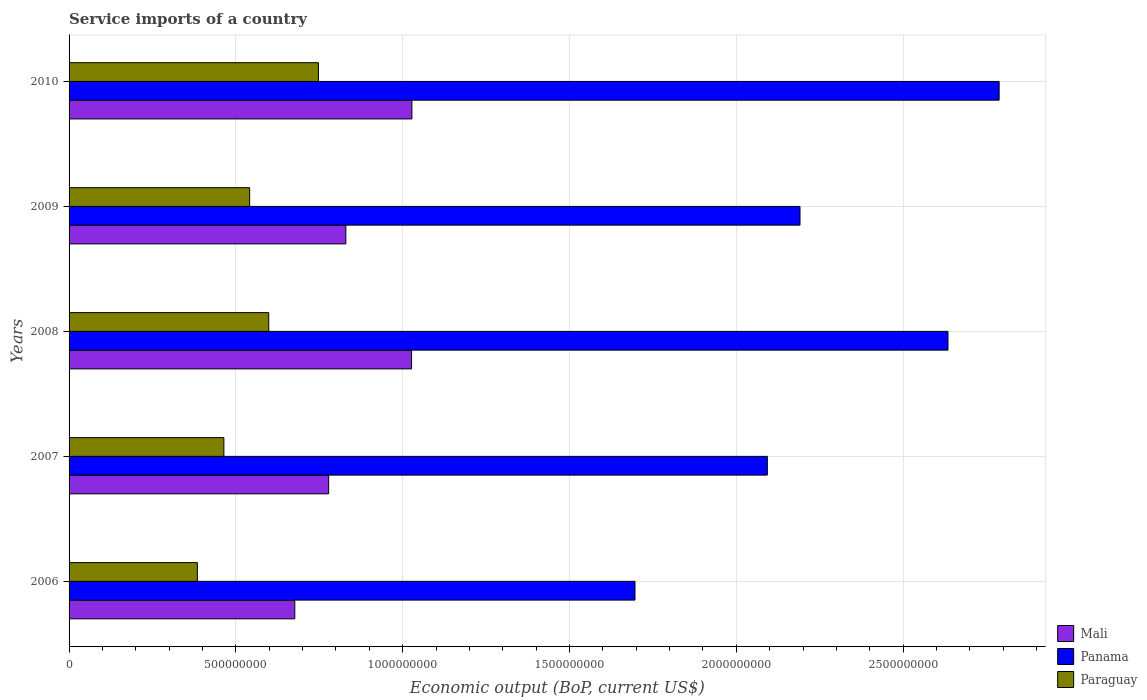Are the number of bars per tick equal to the number of legend labels?
Ensure brevity in your answer.  Yes. Are the number of bars on each tick of the Y-axis equal?
Offer a terse response. Yes. How many bars are there on the 3rd tick from the bottom?
Provide a short and direct response. 3. What is the label of the 4th group of bars from the top?
Your answer should be compact. 2007. What is the service imports in Panama in 2006?
Offer a very short reply. 1.70e+09. Across all years, what is the maximum service imports in Panama?
Ensure brevity in your answer.  2.79e+09. Across all years, what is the minimum service imports in Panama?
Ensure brevity in your answer.  1.70e+09. In which year was the service imports in Paraguay maximum?
Keep it short and to the point. 2010. What is the total service imports in Panama in the graph?
Offer a very short reply. 1.14e+1. What is the difference between the service imports in Panama in 2009 and that in 2010?
Your answer should be compact. -5.97e+08. What is the difference between the service imports in Mali in 2006 and the service imports in Paraguay in 2007?
Your answer should be very brief. 2.13e+08. What is the average service imports in Panama per year?
Your response must be concise. 2.28e+09. In the year 2006, what is the difference between the service imports in Panama and service imports in Mali?
Offer a terse response. 1.02e+09. What is the ratio of the service imports in Paraguay in 2006 to that in 2009?
Your answer should be compact. 0.71. Is the service imports in Panama in 2007 less than that in 2008?
Your answer should be compact. Yes. Is the difference between the service imports in Panama in 2008 and 2010 greater than the difference between the service imports in Mali in 2008 and 2010?
Your response must be concise. No. What is the difference between the highest and the second highest service imports in Panama?
Your answer should be very brief. 1.53e+08. What is the difference between the highest and the lowest service imports in Panama?
Offer a terse response. 1.09e+09. In how many years, is the service imports in Panama greater than the average service imports in Panama taken over all years?
Provide a short and direct response. 2. What does the 2nd bar from the top in 2007 represents?
Provide a short and direct response. Panama. What does the 1st bar from the bottom in 2010 represents?
Give a very brief answer. Mali. Is it the case that in every year, the sum of the service imports in Mali and service imports in Paraguay is greater than the service imports in Panama?
Ensure brevity in your answer.  No. How many bars are there?
Offer a very short reply. 15. What is the difference between two consecutive major ticks on the X-axis?
Give a very brief answer. 5.00e+08. Are the values on the major ticks of X-axis written in scientific E-notation?
Your answer should be compact. No. Does the graph contain any zero values?
Offer a very short reply. No. Does the graph contain grids?
Your response must be concise. Yes. Where does the legend appear in the graph?
Keep it short and to the point. Bottom right. How are the legend labels stacked?
Ensure brevity in your answer.  Vertical. What is the title of the graph?
Keep it short and to the point. Service imports of a country. What is the label or title of the X-axis?
Provide a succinct answer. Economic output (BoP, current US$). What is the label or title of the Y-axis?
Your response must be concise. Years. What is the Economic output (BoP, current US$) of Mali in 2006?
Offer a terse response. 6.77e+08. What is the Economic output (BoP, current US$) of Panama in 2006?
Ensure brevity in your answer.  1.70e+09. What is the Economic output (BoP, current US$) of Paraguay in 2006?
Offer a very short reply. 3.85e+08. What is the Economic output (BoP, current US$) in Mali in 2007?
Give a very brief answer. 7.78e+08. What is the Economic output (BoP, current US$) in Panama in 2007?
Your answer should be compact. 2.09e+09. What is the Economic output (BoP, current US$) in Paraguay in 2007?
Your answer should be very brief. 4.64e+08. What is the Economic output (BoP, current US$) in Mali in 2008?
Your response must be concise. 1.03e+09. What is the Economic output (BoP, current US$) of Panama in 2008?
Your response must be concise. 2.63e+09. What is the Economic output (BoP, current US$) of Paraguay in 2008?
Make the answer very short. 5.99e+08. What is the Economic output (BoP, current US$) in Mali in 2009?
Offer a terse response. 8.30e+08. What is the Economic output (BoP, current US$) of Panama in 2009?
Keep it short and to the point. 2.19e+09. What is the Economic output (BoP, current US$) in Paraguay in 2009?
Your response must be concise. 5.41e+08. What is the Economic output (BoP, current US$) in Mali in 2010?
Keep it short and to the point. 1.03e+09. What is the Economic output (BoP, current US$) of Panama in 2010?
Your response must be concise. 2.79e+09. What is the Economic output (BoP, current US$) in Paraguay in 2010?
Give a very brief answer. 7.47e+08. Across all years, what is the maximum Economic output (BoP, current US$) of Mali?
Your response must be concise. 1.03e+09. Across all years, what is the maximum Economic output (BoP, current US$) in Panama?
Give a very brief answer. 2.79e+09. Across all years, what is the maximum Economic output (BoP, current US$) of Paraguay?
Offer a terse response. 7.47e+08. Across all years, what is the minimum Economic output (BoP, current US$) of Mali?
Provide a succinct answer. 6.77e+08. Across all years, what is the minimum Economic output (BoP, current US$) of Panama?
Your answer should be compact. 1.70e+09. Across all years, what is the minimum Economic output (BoP, current US$) of Paraguay?
Provide a short and direct response. 3.85e+08. What is the total Economic output (BoP, current US$) in Mali in the graph?
Give a very brief answer. 4.34e+09. What is the total Economic output (BoP, current US$) in Panama in the graph?
Offer a very short reply. 1.14e+1. What is the total Economic output (BoP, current US$) in Paraguay in the graph?
Offer a terse response. 2.74e+09. What is the difference between the Economic output (BoP, current US$) of Mali in 2006 and that in 2007?
Make the answer very short. -1.02e+08. What is the difference between the Economic output (BoP, current US$) in Panama in 2006 and that in 2007?
Your answer should be compact. -3.97e+08. What is the difference between the Economic output (BoP, current US$) in Paraguay in 2006 and that in 2007?
Offer a very short reply. -7.95e+07. What is the difference between the Economic output (BoP, current US$) of Mali in 2006 and that in 2008?
Give a very brief answer. -3.50e+08. What is the difference between the Economic output (BoP, current US$) of Panama in 2006 and that in 2008?
Your response must be concise. -9.38e+08. What is the difference between the Economic output (BoP, current US$) in Paraguay in 2006 and that in 2008?
Offer a terse response. -2.14e+08. What is the difference between the Economic output (BoP, current US$) of Mali in 2006 and that in 2009?
Offer a very short reply. -1.53e+08. What is the difference between the Economic output (BoP, current US$) of Panama in 2006 and that in 2009?
Provide a short and direct response. -4.95e+08. What is the difference between the Economic output (BoP, current US$) in Paraguay in 2006 and that in 2009?
Keep it short and to the point. -1.57e+08. What is the difference between the Economic output (BoP, current US$) of Mali in 2006 and that in 2010?
Your answer should be compact. -3.51e+08. What is the difference between the Economic output (BoP, current US$) of Panama in 2006 and that in 2010?
Provide a succinct answer. -1.09e+09. What is the difference between the Economic output (BoP, current US$) of Paraguay in 2006 and that in 2010?
Your answer should be compact. -3.63e+08. What is the difference between the Economic output (BoP, current US$) in Mali in 2007 and that in 2008?
Your answer should be compact. -2.48e+08. What is the difference between the Economic output (BoP, current US$) in Panama in 2007 and that in 2008?
Give a very brief answer. -5.41e+08. What is the difference between the Economic output (BoP, current US$) in Paraguay in 2007 and that in 2008?
Keep it short and to the point. -1.35e+08. What is the difference between the Economic output (BoP, current US$) in Mali in 2007 and that in 2009?
Provide a short and direct response. -5.15e+07. What is the difference between the Economic output (BoP, current US$) of Panama in 2007 and that in 2009?
Provide a succinct answer. -9.79e+07. What is the difference between the Economic output (BoP, current US$) in Paraguay in 2007 and that in 2009?
Offer a very short reply. -7.72e+07. What is the difference between the Economic output (BoP, current US$) of Mali in 2007 and that in 2010?
Make the answer very short. -2.49e+08. What is the difference between the Economic output (BoP, current US$) in Panama in 2007 and that in 2010?
Offer a terse response. -6.95e+08. What is the difference between the Economic output (BoP, current US$) in Paraguay in 2007 and that in 2010?
Your answer should be very brief. -2.83e+08. What is the difference between the Economic output (BoP, current US$) in Mali in 2008 and that in 2009?
Offer a very short reply. 1.97e+08. What is the difference between the Economic output (BoP, current US$) in Panama in 2008 and that in 2009?
Your answer should be very brief. 4.44e+08. What is the difference between the Economic output (BoP, current US$) of Paraguay in 2008 and that in 2009?
Your response must be concise. 5.73e+07. What is the difference between the Economic output (BoP, current US$) of Mali in 2008 and that in 2010?
Your answer should be very brief. -1.00e+06. What is the difference between the Economic output (BoP, current US$) of Panama in 2008 and that in 2010?
Give a very brief answer. -1.53e+08. What is the difference between the Economic output (BoP, current US$) in Paraguay in 2008 and that in 2010?
Keep it short and to the point. -1.49e+08. What is the difference between the Economic output (BoP, current US$) in Mali in 2009 and that in 2010?
Make the answer very short. -1.98e+08. What is the difference between the Economic output (BoP, current US$) of Panama in 2009 and that in 2010?
Offer a terse response. -5.97e+08. What is the difference between the Economic output (BoP, current US$) of Paraguay in 2009 and that in 2010?
Your answer should be compact. -2.06e+08. What is the difference between the Economic output (BoP, current US$) in Mali in 2006 and the Economic output (BoP, current US$) in Panama in 2007?
Give a very brief answer. -1.42e+09. What is the difference between the Economic output (BoP, current US$) in Mali in 2006 and the Economic output (BoP, current US$) in Paraguay in 2007?
Your answer should be very brief. 2.13e+08. What is the difference between the Economic output (BoP, current US$) of Panama in 2006 and the Economic output (BoP, current US$) of Paraguay in 2007?
Provide a succinct answer. 1.23e+09. What is the difference between the Economic output (BoP, current US$) of Mali in 2006 and the Economic output (BoP, current US$) of Panama in 2008?
Make the answer very short. -1.96e+09. What is the difference between the Economic output (BoP, current US$) of Mali in 2006 and the Economic output (BoP, current US$) of Paraguay in 2008?
Offer a terse response. 7.81e+07. What is the difference between the Economic output (BoP, current US$) of Panama in 2006 and the Economic output (BoP, current US$) of Paraguay in 2008?
Your response must be concise. 1.10e+09. What is the difference between the Economic output (BoP, current US$) in Mali in 2006 and the Economic output (BoP, current US$) in Panama in 2009?
Make the answer very short. -1.51e+09. What is the difference between the Economic output (BoP, current US$) in Mali in 2006 and the Economic output (BoP, current US$) in Paraguay in 2009?
Give a very brief answer. 1.35e+08. What is the difference between the Economic output (BoP, current US$) of Panama in 2006 and the Economic output (BoP, current US$) of Paraguay in 2009?
Make the answer very short. 1.16e+09. What is the difference between the Economic output (BoP, current US$) of Mali in 2006 and the Economic output (BoP, current US$) of Panama in 2010?
Provide a short and direct response. -2.11e+09. What is the difference between the Economic output (BoP, current US$) in Mali in 2006 and the Economic output (BoP, current US$) in Paraguay in 2010?
Offer a terse response. -7.08e+07. What is the difference between the Economic output (BoP, current US$) of Panama in 2006 and the Economic output (BoP, current US$) of Paraguay in 2010?
Keep it short and to the point. 9.49e+08. What is the difference between the Economic output (BoP, current US$) of Mali in 2007 and the Economic output (BoP, current US$) of Panama in 2008?
Provide a short and direct response. -1.86e+09. What is the difference between the Economic output (BoP, current US$) of Mali in 2007 and the Economic output (BoP, current US$) of Paraguay in 2008?
Offer a very short reply. 1.80e+08. What is the difference between the Economic output (BoP, current US$) in Panama in 2007 and the Economic output (BoP, current US$) in Paraguay in 2008?
Keep it short and to the point. 1.49e+09. What is the difference between the Economic output (BoP, current US$) in Mali in 2007 and the Economic output (BoP, current US$) in Panama in 2009?
Provide a short and direct response. -1.41e+09. What is the difference between the Economic output (BoP, current US$) in Mali in 2007 and the Economic output (BoP, current US$) in Paraguay in 2009?
Ensure brevity in your answer.  2.37e+08. What is the difference between the Economic output (BoP, current US$) of Panama in 2007 and the Economic output (BoP, current US$) of Paraguay in 2009?
Your answer should be very brief. 1.55e+09. What is the difference between the Economic output (BoP, current US$) in Mali in 2007 and the Economic output (BoP, current US$) in Panama in 2010?
Your answer should be very brief. -2.01e+09. What is the difference between the Economic output (BoP, current US$) of Mali in 2007 and the Economic output (BoP, current US$) of Paraguay in 2010?
Ensure brevity in your answer.  3.07e+07. What is the difference between the Economic output (BoP, current US$) in Panama in 2007 and the Economic output (BoP, current US$) in Paraguay in 2010?
Provide a succinct answer. 1.35e+09. What is the difference between the Economic output (BoP, current US$) in Mali in 2008 and the Economic output (BoP, current US$) in Panama in 2009?
Offer a very short reply. -1.16e+09. What is the difference between the Economic output (BoP, current US$) of Mali in 2008 and the Economic output (BoP, current US$) of Paraguay in 2009?
Make the answer very short. 4.85e+08. What is the difference between the Economic output (BoP, current US$) in Panama in 2008 and the Economic output (BoP, current US$) in Paraguay in 2009?
Provide a succinct answer. 2.09e+09. What is the difference between the Economic output (BoP, current US$) in Mali in 2008 and the Economic output (BoP, current US$) in Panama in 2010?
Keep it short and to the point. -1.76e+09. What is the difference between the Economic output (BoP, current US$) in Mali in 2008 and the Economic output (BoP, current US$) in Paraguay in 2010?
Ensure brevity in your answer.  2.79e+08. What is the difference between the Economic output (BoP, current US$) in Panama in 2008 and the Economic output (BoP, current US$) in Paraguay in 2010?
Give a very brief answer. 1.89e+09. What is the difference between the Economic output (BoP, current US$) in Mali in 2009 and the Economic output (BoP, current US$) in Panama in 2010?
Provide a short and direct response. -1.96e+09. What is the difference between the Economic output (BoP, current US$) in Mali in 2009 and the Economic output (BoP, current US$) in Paraguay in 2010?
Ensure brevity in your answer.  8.21e+07. What is the difference between the Economic output (BoP, current US$) in Panama in 2009 and the Economic output (BoP, current US$) in Paraguay in 2010?
Offer a terse response. 1.44e+09. What is the average Economic output (BoP, current US$) in Mali per year?
Ensure brevity in your answer.  8.68e+08. What is the average Economic output (BoP, current US$) of Panama per year?
Provide a succinct answer. 2.28e+09. What is the average Economic output (BoP, current US$) of Paraguay per year?
Offer a very short reply. 5.47e+08. In the year 2006, what is the difference between the Economic output (BoP, current US$) of Mali and Economic output (BoP, current US$) of Panama?
Your answer should be compact. -1.02e+09. In the year 2006, what is the difference between the Economic output (BoP, current US$) of Mali and Economic output (BoP, current US$) of Paraguay?
Ensure brevity in your answer.  2.92e+08. In the year 2006, what is the difference between the Economic output (BoP, current US$) in Panama and Economic output (BoP, current US$) in Paraguay?
Provide a succinct answer. 1.31e+09. In the year 2007, what is the difference between the Economic output (BoP, current US$) of Mali and Economic output (BoP, current US$) of Panama?
Make the answer very short. -1.31e+09. In the year 2007, what is the difference between the Economic output (BoP, current US$) in Mali and Economic output (BoP, current US$) in Paraguay?
Your response must be concise. 3.14e+08. In the year 2007, what is the difference between the Economic output (BoP, current US$) in Panama and Economic output (BoP, current US$) in Paraguay?
Give a very brief answer. 1.63e+09. In the year 2008, what is the difference between the Economic output (BoP, current US$) of Mali and Economic output (BoP, current US$) of Panama?
Give a very brief answer. -1.61e+09. In the year 2008, what is the difference between the Economic output (BoP, current US$) in Mali and Economic output (BoP, current US$) in Paraguay?
Offer a terse response. 4.28e+08. In the year 2008, what is the difference between the Economic output (BoP, current US$) in Panama and Economic output (BoP, current US$) in Paraguay?
Ensure brevity in your answer.  2.04e+09. In the year 2009, what is the difference between the Economic output (BoP, current US$) in Mali and Economic output (BoP, current US$) in Panama?
Provide a succinct answer. -1.36e+09. In the year 2009, what is the difference between the Economic output (BoP, current US$) in Mali and Economic output (BoP, current US$) in Paraguay?
Provide a short and direct response. 2.88e+08. In the year 2009, what is the difference between the Economic output (BoP, current US$) in Panama and Economic output (BoP, current US$) in Paraguay?
Your answer should be compact. 1.65e+09. In the year 2010, what is the difference between the Economic output (BoP, current US$) in Mali and Economic output (BoP, current US$) in Panama?
Make the answer very short. -1.76e+09. In the year 2010, what is the difference between the Economic output (BoP, current US$) of Mali and Economic output (BoP, current US$) of Paraguay?
Your answer should be very brief. 2.80e+08. In the year 2010, what is the difference between the Economic output (BoP, current US$) of Panama and Economic output (BoP, current US$) of Paraguay?
Give a very brief answer. 2.04e+09. What is the ratio of the Economic output (BoP, current US$) of Mali in 2006 to that in 2007?
Give a very brief answer. 0.87. What is the ratio of the Economic output (BoP, current US$) of Panama in 2006 to that in 2007?
Offer a very short reply. 0.81. What is the ratio of the Economic output (BoP, current US$) of Paraguay in 2006 to that in 2007?
Make the answer very short. 0.83. What is the ratio of the Economic output (BoP, current US$) of Mali in 2006 to that in 2008?
Make the answer very short. 0.66. What is the ratio of the Economic output (BoP, current US$) in Panama in 2006 to that in 2008?
Keep it short and to the point. 0.64. What is the ratio of the Economic output (BoP, current US$) of Paraguay in 2006 to that in 2008?
Your answer should be very brief. 0.64. What is the ratio of the Economic output (BoP, current US$) of Mali in 2006 to that in 2009?
Keep it short and to the point. 0.82. What is the ratio of the Economic output (BoP, current US$) in Panama in 2006 to that in 2009?
Keep it short and to the point. 0.77. What is the ratio of the Economic output (BoP, current US$) of Paraguay in 2006 to that in 2009?
Your answer should be compact. 0.71. What is the ratio of the Economic output (BoP, current US$) of Mali in 2006 to that in 2010?
Provide a short and direct response. 0.66. What is the ratio of the Economic output (BoP, current US$) in Panama in 2006 to that in 2010?
Provide a succinct answer. 0.61. What is the ratio of the Economic output (BoP, current US$) in Paraguay in 2006 to that in 2010?
Your answer should be compact. 0.51. What is the ratio of the Economic output (BoP, current US$) of Mali in 2007 to that in 2008?
Provide a short and direct response. 0.76. What is the ratio of the Economic output (BoP, current US$) of Panama in 2007 to that in 2008?
Offer a terse response. 0.79. What is the ratio of the Economic output (BoP, current US$) in Paraguay in 2007 to that in 2008?
Make the answer very short. 0.78. What is the ratio of the Economic output (BoP, current US$) in Mali in 2007 to that in 2009?
Ensure brevity in your answer.  0.94. What is the ratio of the Economic output (BoP, current US$) in Panama in 2007 to that in 2009?
Offer a terse response. 0.96. What is the ratio of the Economic output (BoP, current US$) in Paraguay in 2007 to that in 2009?
Provide a short and direct response. 0.86. What is the ratio of the Economic output (BoP, current US$) of Mali in 2007 to that in 2010?
Your response must be concise. 0.76. What is the ratio of the Economic output (BoP, current US$) in Panama in 2007 to that in 2010?
Offer a terse response. 0.75. What is the ratio of the Economic output (BoP, current US$) in Paraguay in 2007 to that in 2010?
Offer a terse response. 0.62. What is the ratio of the Economic output (BoP, current US$) of Mali in 2008 to that in 2009?
Give a very brief answer. 1.24. What is the ratio of the Economic output (BoP, current US$) of Panama in 2008 to that in 2009?
Your response must be concise. 1.2. What is the ratio of the Economic output (BoP, current US$) of Paraguay in 2008 to that in 2009?
Keep it short and to the point. 1.11. What is the ratio of the Economic output (BoP, current US$) in Mali in 2008 to that in 2010?
Offer a very short reply. 1. What is the ratio of the Economic output (BoP, current US$) in Panama in 2008 to that in 2010?
Provide a succinct answer. 0.94. What is the ratio of the Economic output (BoP, current US$) in Paraguay in 2008 to that in 2010?
Keep it short and to the point. 0.8. What is the ratio of the Economic output (BoP, current US$) of Mali in 2009 to that in 2010?
Provide a short and direct response. 0.81. What is the ratio of the Economic output (BoP, current US$) in Panama in 2009 to that in 2010?
Offer a terse response. 0.79. What is the ratio of the Economic output (BoP, current US$) of Paraguay in 2009 to that in 2010?
Provide a succinct answer. 0.72. What is the difference between the highest and the second highest Economic output (BoP, current US$) of Mali?
Provide a succinct answer. 1.00e+06. What is the difference between the highest and the second highest Economic output (BoP, current US$) of Panama?
Offer a very short reply. 1.53e+08. What is the difference between the highest and the second highest Economic output (BoP, current US$) of Paraguay?
Give a very brief answer. 1.49e+08. What is the difference between the highest and the lowest Economic output (BoP, current US$) in Mali?
Offer a very short reply. 3.51e+08. What is the difference between the highest and the lowest Economic output (BoP, current US$) of Panama?
Your response must be concise. 1.09e+09. What is the difference between the highest and the lowest Economic output (BoP, current US$) in Paraguay?
Give a very brief answer. 3.63e+08. 